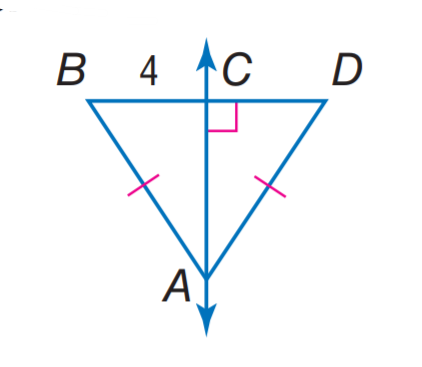Question: Find C D.
Choices:
A. 2
B. 4
C. 8
D. 12
Answer with the letter. Answer: B 